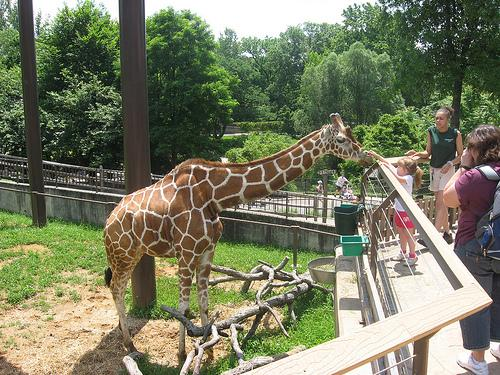Narrate the key scenes and individuals present in the image. A child in red shorts meets a friendly giraffe, while a woman wearing purple snaps a photo of the encounter. Write a brief description of the main subject and the actions taking place in the image. A child in red shorts pets a friendly giraffe, while a nearby woman in a purple outfit snaps a photo of the interaction. List the main subjects, colors, and events that can be seen in the image. Giraffe with large brown spots, girl in red shorts and white shirt petting the giraffe, woman in purple shirt taking a photograph. Describe the primary subjects and events depicted in the image in detail. An affectionate girl wearing a white shirt and red shorts pets a large, brown-spotted giraffe, while a woman in a dark purple shirt photographs the heartwarming moment. Explain the significant elements and occurrences displayed in the photograph. A giraffe with a long neck is being caressed by a little girl dressed in red shorts, while another woman clothed in a purple shirt is taking a photograph of the moment. Summarize the primary objects, colors and activities in the snapshot. A large brown-spotted giraffe is interacted with a girl wearing a white shirt and red shorts, while a woman in a purple shirt photographs the scene. Create a sentence or two describing the key subjects and happenings within the picture. A giraffe with brown spots bends toward a girl in red shorts who pets it gently, while a woman decked out in purple takes a photo of the tender moment. In your own words, express the main subjects and events happening in the image. A young girl in red shorts is touching a giraffe, as a lady in a purple top captures the moment with a camera. Identify the main characters and their actions within the image. A giraffe and a girl in red shorts share a special moment as she pets it, and a woman in a purple top captures the memory with her camera. Provide a simple overview of the main subject and actions taking place within the image. A giraffe is being petted by a girl in red shorts, while a woman in a purple shirt takes their photo. 